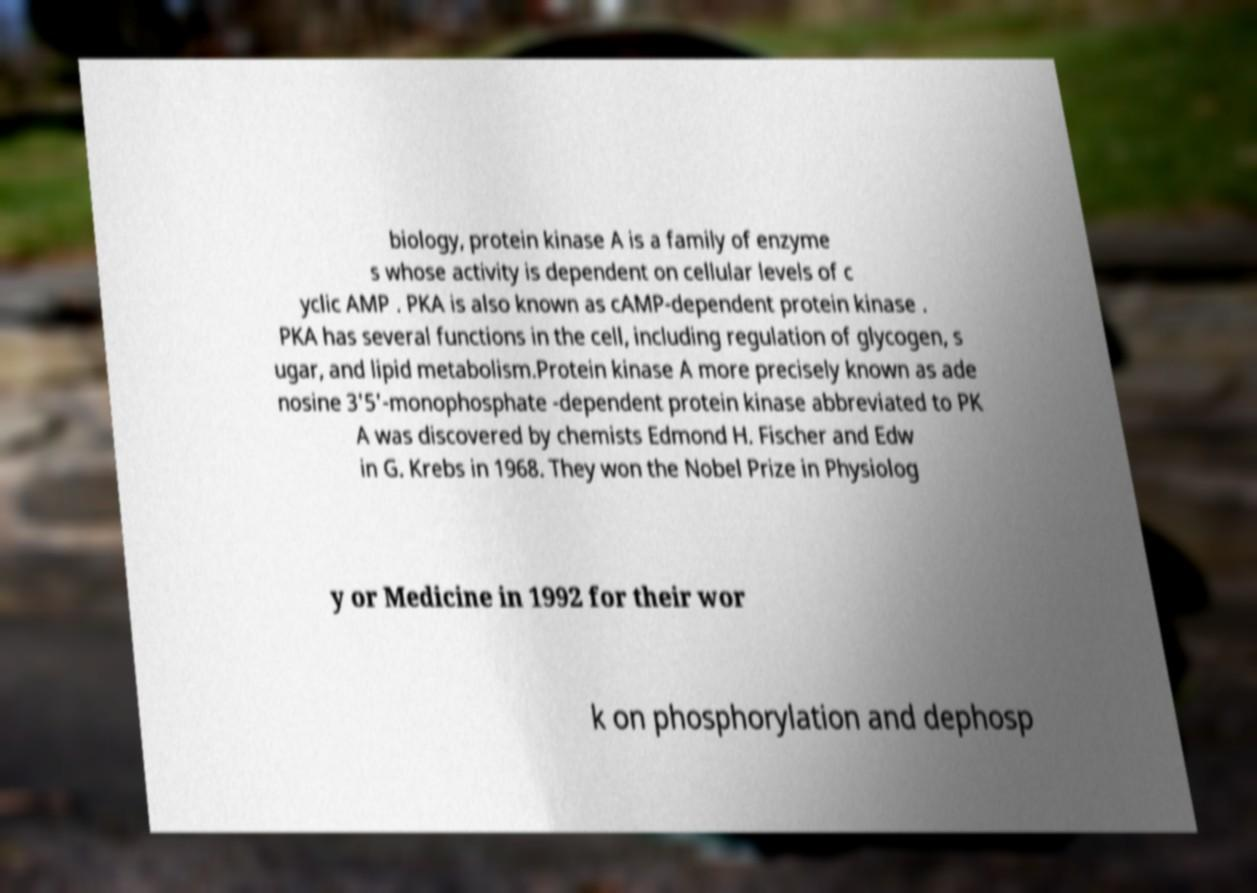Can you accurately transcribe the text from the provided image for me? biology, protein kinase A is a family of enzyme s whose activity is dependent on cellular levels of c yclic AMP . PKA is also known as cAMP-dependent protein kinase . PKA has several functions in the cell, including regulation of glycogen, s ugar, and lipid metabolism.Protein kinase A more precisely known as ade nosine 3'5'-monophosphate -dependent protein kinase abbreviated to PK A was discovered by chemists Edmond H. Fischer and Edw in G. Krebs in 1968. They won the Nobel Prize in Physiolog y or Medicine in 1992 for their wor k on phosphorylation and dephosp 